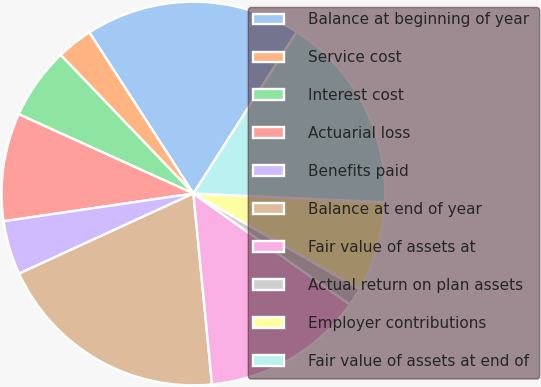<chart> <loc_0><loc_0><loc_500><loc_500><pie_chart><fcel>Balance at beginning of year<fcel>Service cost<fcel>Interest cost<fcel>Actuarial loss<fcel>Benefits paid<fcel>Balance at end of year<fcel>Fair value of assets at<fcel>Actual return on plan assets<fcel>Employer contributions<fcel>Fair value of assets at end of<nl><fcel>18.18%<fcel>3.03%<fcel>6.06%<fcel>9.09%<fcel>4.55%<fcel>19.69%<fcel>13.63%<fcel>1.52%<fcel>7.58%<fcel>16.66%<nl></chart> 